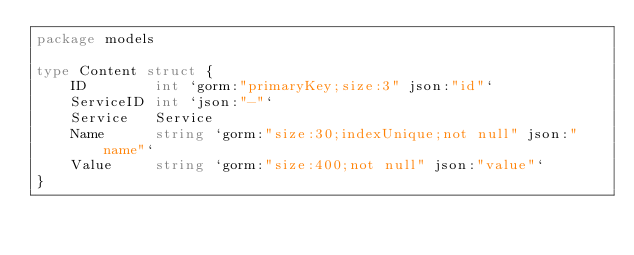Convert code to text. <code><loc_0><loc_0><loc_500><loc_500><_Go_>package models

type Content struct {
	ID        int `gorm:"primaryKey;size:3" json:"id"`
	ServiceID int `json:"-"`
	Service   Service
	Name      string `gorm:"size:30;indexUnique;not null" json:"name"`
	Value     string `gorm:"size:400;not null" json:"value"`
}
</code> 